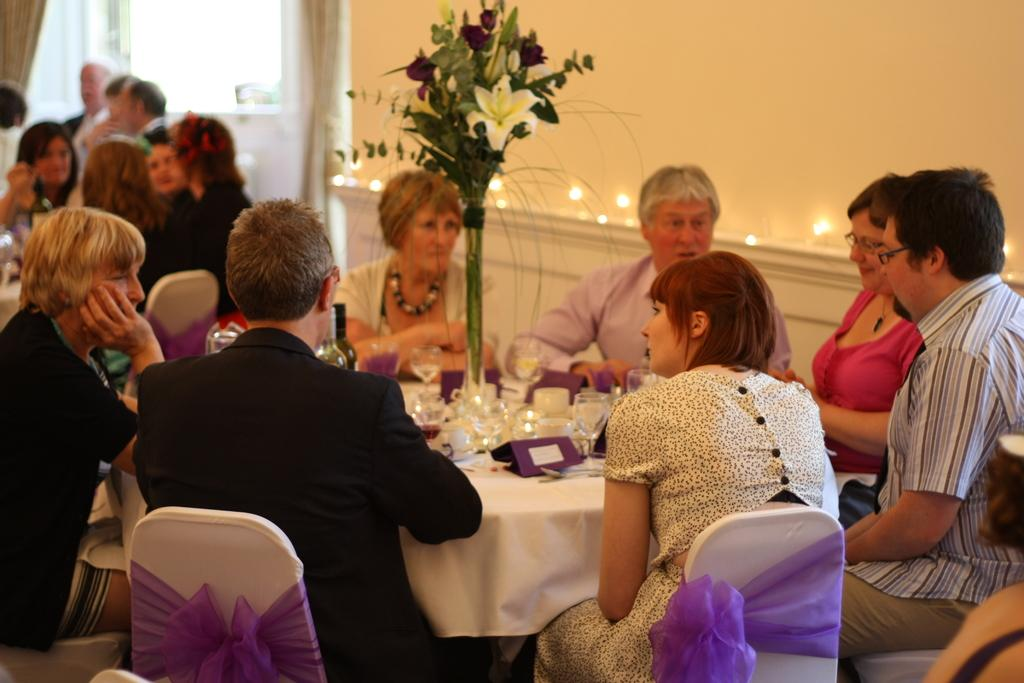What are the persons in the image doing? The persons in the image are sitting on a chair. What objects can be seen on the table in the image? There are glasses and a flower vase on a table in the image. What type of vegetable is being used as a rake in the image? There is no vegetable or rake present in the image. 